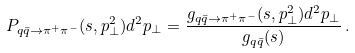<formula> <loc_0><loc_0><loc_500><loc_500>P _ { q \bar { q } \to \pi ^ { + } \pi ^ { - } } ( s , p _ { \perp } ^ { 2 } ) d ^ { 2 } { p _ { \perp } } = \frac { g _ { q \bar { q } \to \pi ^ { + } \pi ^ { - } } ( s , p _ { \perp } ^ { 2 } ) d ^ { 2 } { p _ { \perp } } } { g _ { q \bar { q } } ( s ) } \, .</formula> 